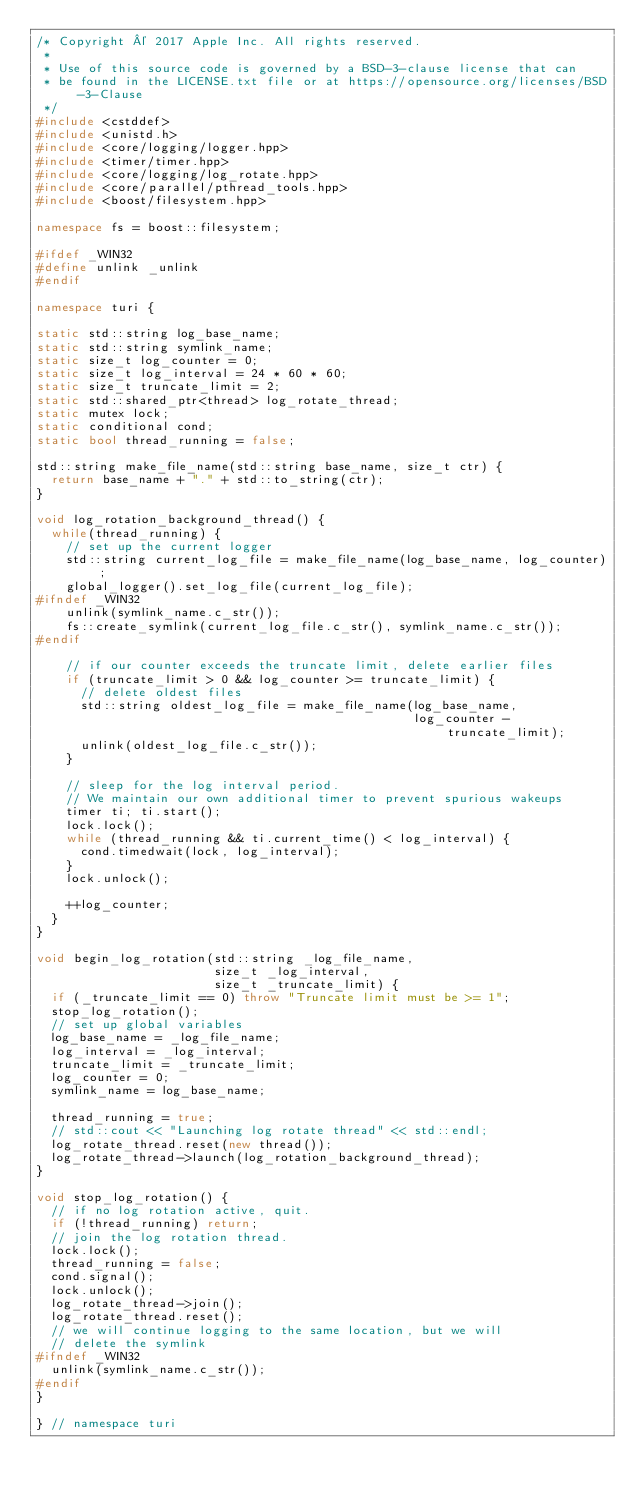<code> <loc_0><loc_0><loc_500><loc_500><_C++_>/* Copyright © 2017 Apple Inc. All rights reserved.
 *
 * Use of this source code is governed by a BSD-3-clause license that can
 * be found in the LICENSE.txt file or at https://opensource.org/licenses/BSD-3-Clause
 */
#include <cstddef>
#include <unistd.h>
#include <core/logging/logger.hpp>
#include <timer/timer.hpp>
#include <core/logging/log_rotate.hpp>
#include <core/parallel/pthread_tools.hpp>
#include <boost/filesystem.hpp>

namespace fs = boost::filesystem;

#ifdef _WIN32
#define unlink _unlink
#endif

namespace turi {

static std::string log_base_name;
static std::string symlink_name;
static size_t log_counter = 0;
static size_t log_interval = 24 * 60 * 60;
static size_t truncate_limit = 2;
static std::shared_ptr<thread> log_rotate_thread;
static mutex lock;
static conditional cond;
static bool thread_running = false;

std::string make_file_name(std::string base_name, size_t ctr) {
  return base_name + "." + std::to_string(ctr);
}

void log_rotation_background_thread() {
  while(thread_running) {
    // set up the current logger
    std::string current_log_file = make_file_name(log_base_name, log_counter);
    global_logger().set_log_file(current_log_file);
#ifndef _WIN32
    unlink(symlink_name.c_str());
    fs::create_symlink(current_log_file.c_str(), symlink_name.c_str());
#endif

    // if our counter exceeds the truncate limit, delete earlier files
    if (truncate_limit > 0 && log_counter >= truncate_limit) {
      // delete oldest files
      std::string oldest_log_file = make_file_name(log_base_name,
                                                   log_counter - truncate_limit);
      unlink(oldest_log_file.c_str());
    }

    // sleep for the log interval period.
    // We maintain our own additional timer to prevent spurious wakeups
    timer ti; ti.start();
    lock.lock();
    while (thread_running && ti.current_time() < log_interval) {
      cond.timedwait(lock, log_interval);
    }
    lock.unlock();

    ++log_counter;
  }
}

void begin_log_rotation(std::string _log_file_name,
                        size_t _log_interval,
                        size_t _truncate_limit) {
  if (_truncate_limit == 0) throw "Truncate limit must be >= 1";
  stop_log_rotation();
  // set up global variables
  log_base_name = _log_file_name;
  log_interval = _log_interval;
  truncate_limit = _truncate_limit;
  log_counter = 0;
  symlink_name = log_base_name;

  thread_running = true;
  // std::cout << "Launching log rotate thread" << std::endl;
  log_rotate_thread.reset(new thread());
  log_rotate_thread->launch(log_rotation_background_thread);
}

void stop_log_rotation() {
  // if no log rotation active, quit.
  if (!thread_running) return;
  // join the log rotation thread.
  lock.lock();
  thread_running = false;
  cond.signal();
  lock.unlock();
  log_rotate_thread->join();
  log_rotate_thread.reset();
  // we will continue logging to the same location, but we will
  // delete the symlink
#ifndef _WIN32
  unlink(symlink_name.c_str());
#endif
}

} // namespace turi
</code> 